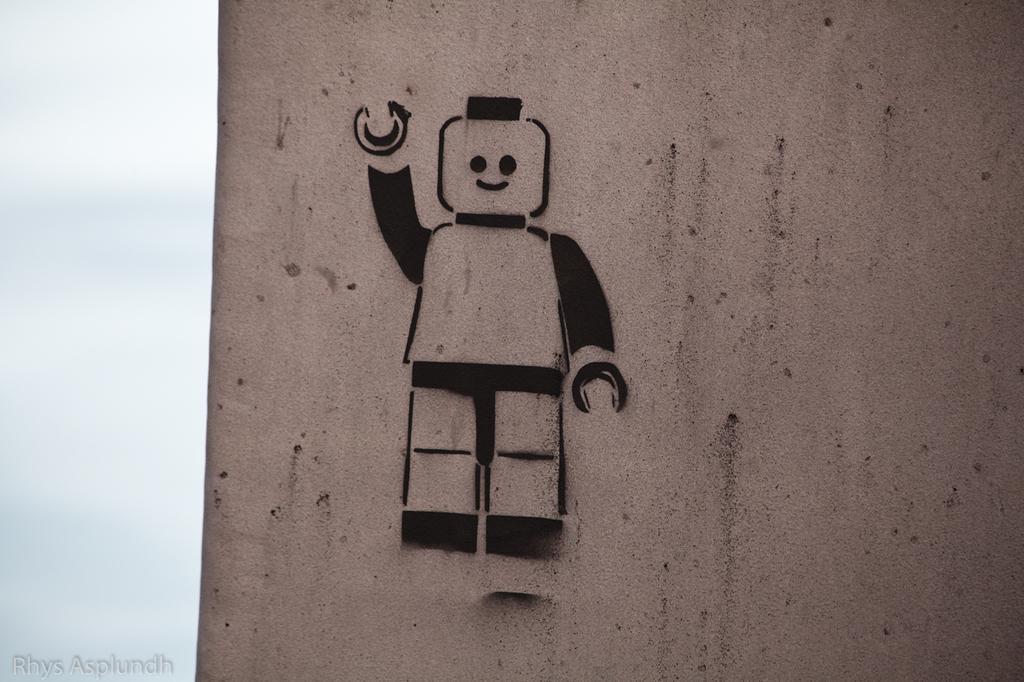Please provide a concise description of this image. Here in this picture we can see a sketch designed in the shape of robot present on a wall and we can see the sky is cloudy. 